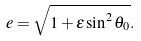Convert formula to latex. <formula><loc_0><loc_0><loc_500><loc_500>e = \sqrt { 1 + \varepsilon \sin ^ { 2 } \theta _ { 0 } } .</formula> 